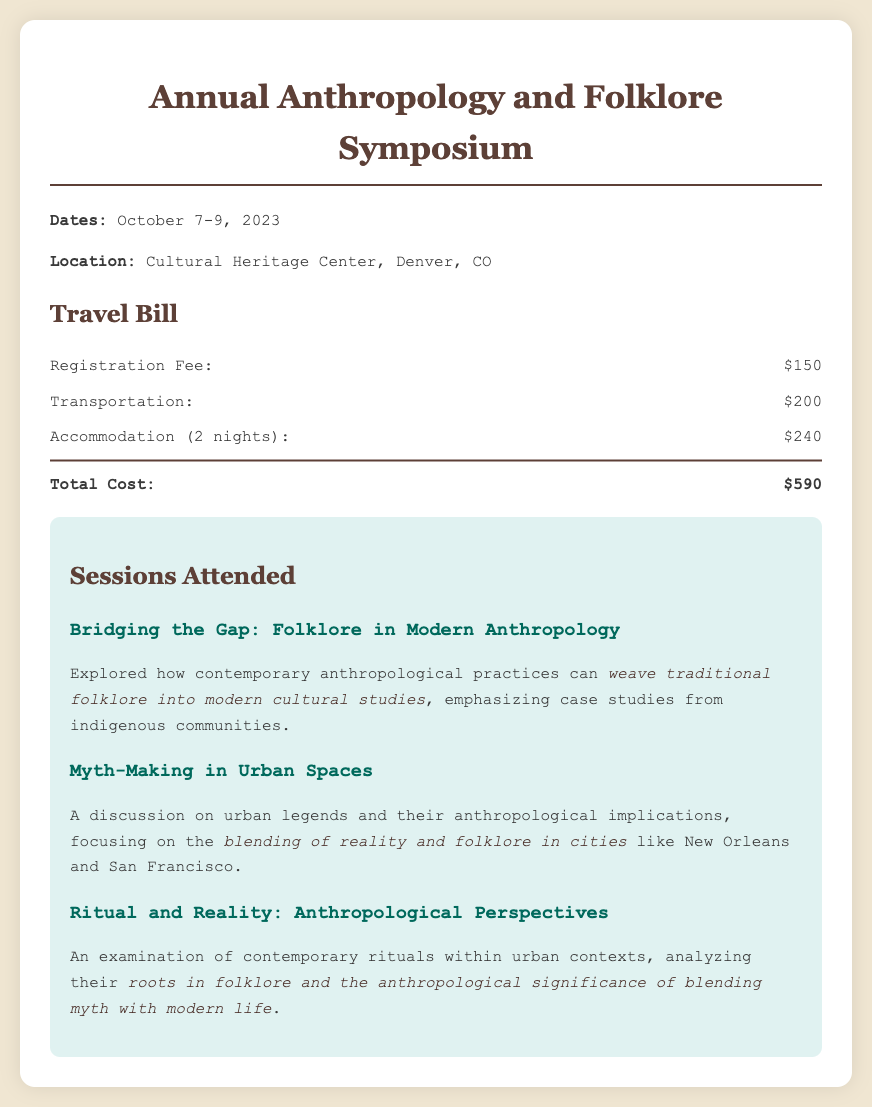What is the registration fee? The registration fee is explicitly listed in the document as $150.
Answer: $150 What are the dates of the conference? The document states that the conference dates are October 7-9, 2023.
Answer: October 7-9, 2023 How much was spent on transportation? The document indicates that the transportation cost is $200.
Answer: $200 What is the total cost of the trip? The total cost is the sum of the registration fee, transportation, and accommodation, which equals $590.
Answer: $590 Which session discussed urban legends? The session titled "Myth-Making in Urban Spaces" focuses on urban legends and their implications.
Answer: Myth-Making in Urban Spaces How many nights of accommodation were included? The document specifies that the accommodation cost covers 2 nights.
Answer: 2 nights What is the price for accommodations? The accommodation cost is stated as $240 for 2 nights.
Answer: $240 What theme does "Bridging the Gap" address? It addresses how to weave traditional folklore into modern cultural studies in anthropology.
Answer: Traditional folklore into modern cultural studies In which city is the conference held? The document states that the conference is located in Denver, CO.
Answer: Denver, CO 